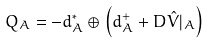<formula> <loc_0><loc_0><loc_500><loc_500>Q _ { A } = - d ^ { * } _ { A } \oplus \left ( d ^ { + } _ { A } + D \hat { V } | _ { A } \right )</formula> 